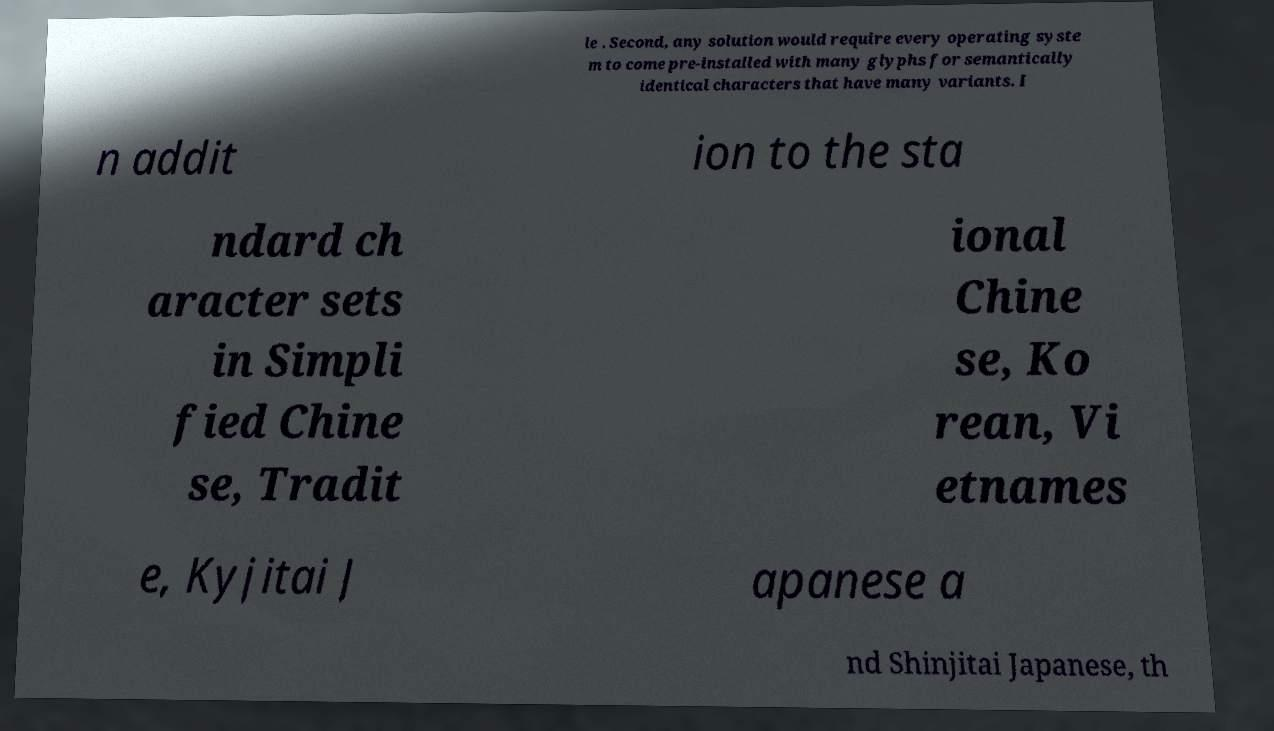For documentation purposes, I need the text within this image transcribed. Could you provide that? le . Second, any solution would require every operating syste m to come pre-installed with many glyphs for semantically identical characters that have many variants. I n addit ion to the sta ndard ch aracter sets in Simpli fied Chine se, Tradit ional Chine se, Ko rean, Vi etnames e, Kyjitai J apanese a nd Shinjitai Japanese, th 